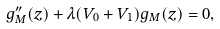<formula> <loc_0><loc_0><loc_500><loc_500>g ^ { \prime \prime } _ { M } ( z ) + \lambda ( V _ { 0 } + V _ { 1 } ) g _ { M } ( z ) = 0 ,</formula> 